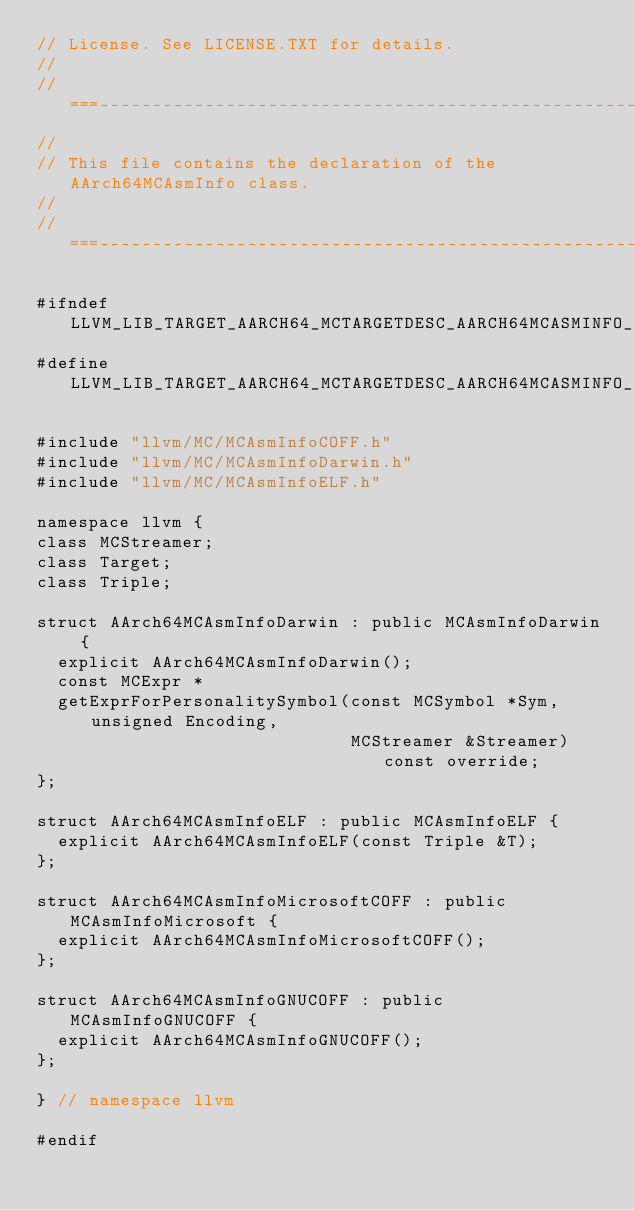Convert code to text. <code><loc_0><loc_0><loc_500><loc_500><_C_>// License. See LICENSE.TXT for details.
//
//===----------------------------------------------------------------------===//
//
// This file contains the declaration of the AArch64MCAsmInfo class.
//
//===----------------------------------------------------------------------===//

#ifndef LLVM_LIB_TARGET_AARCH64_MCTARGETDESC_AARCH64MCASMINFO_H
#define LLVM_LIB_TARGET_AARCH64_MCTARGETDESC_AARCH64MCASMINFO_H

#include "llvm/MC/MCAsmInfoCOFF.h"
#include "llvm/MC/MCAsmInfoDarwin.h"
#include "llvm/MC/MCAsmInfoELF.h"

namespace llvm {
class MCStreamer;
class Target;
class Triple;

struct AArch64MCAsmInfoDarwin : public MCAsmInfoDarwin {
  explicit AArch64MCAsmInfoDarwin();
  const MCExpr *
  getExprForPersonalitySymbol(const MCSymbol *Sym, unsigned Encoding,
                              MCStreamer &Streamer) const override;
};

struct AArch64MCAsmInfoELF : public MCAsmInfoELF {
  explicit AArch64MCAsmInfoELF(const Triple &T);
};

struct AArch64MCAsmInfoMicrosoftCOFF : public MCAsmInfoMicrosoft {
  explicit AArch64MCAsmInfoMicrosoftCOFF();
};

struct AArch64MCAsmInfoGNUCOFF : public MCAsmInfoGNUCOFF {
  explicit AArch64MCAsmInfoGNUCOFF();
};

} // namespace llvm

#endif
</code> 